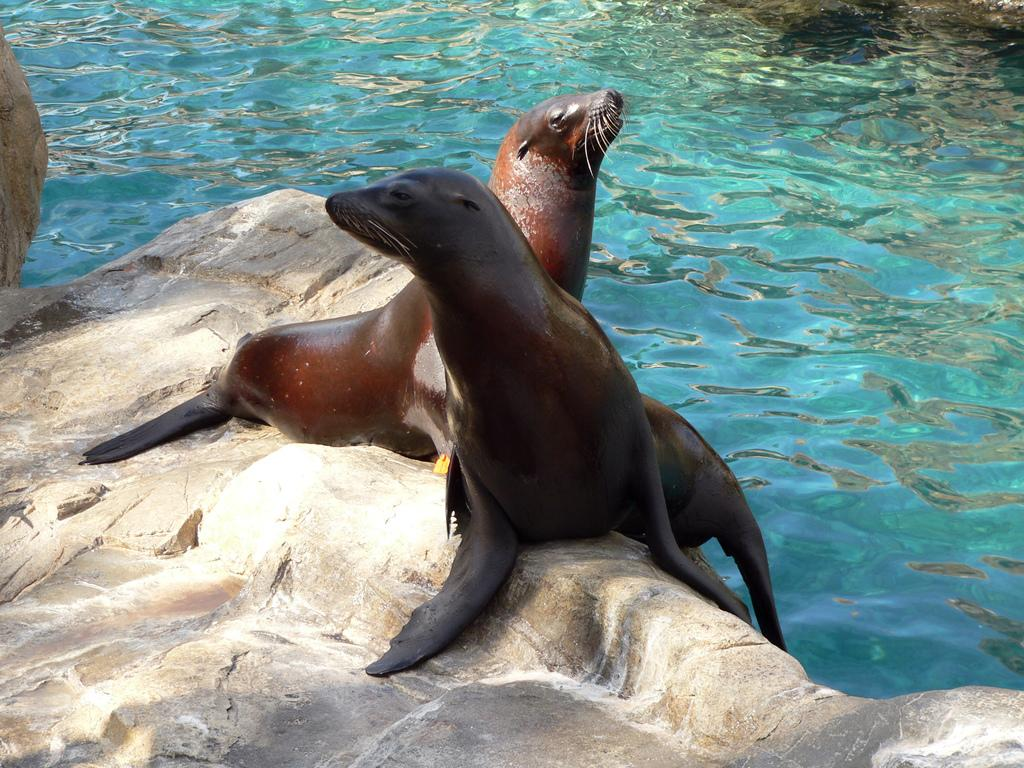What types of animals are in the image? There are two sea animals in the image. Where are the sea animals located? The sea animals are on a rock. What natural element is visible in the image? There is water visible in the image. What is the rate of the sea animals' swimming in the image? The image does not provide information about the rate of the sea animals' swimming. Who is the owner of the sea animals in the image? The image does not provide information about the ownership of the sea animals. 